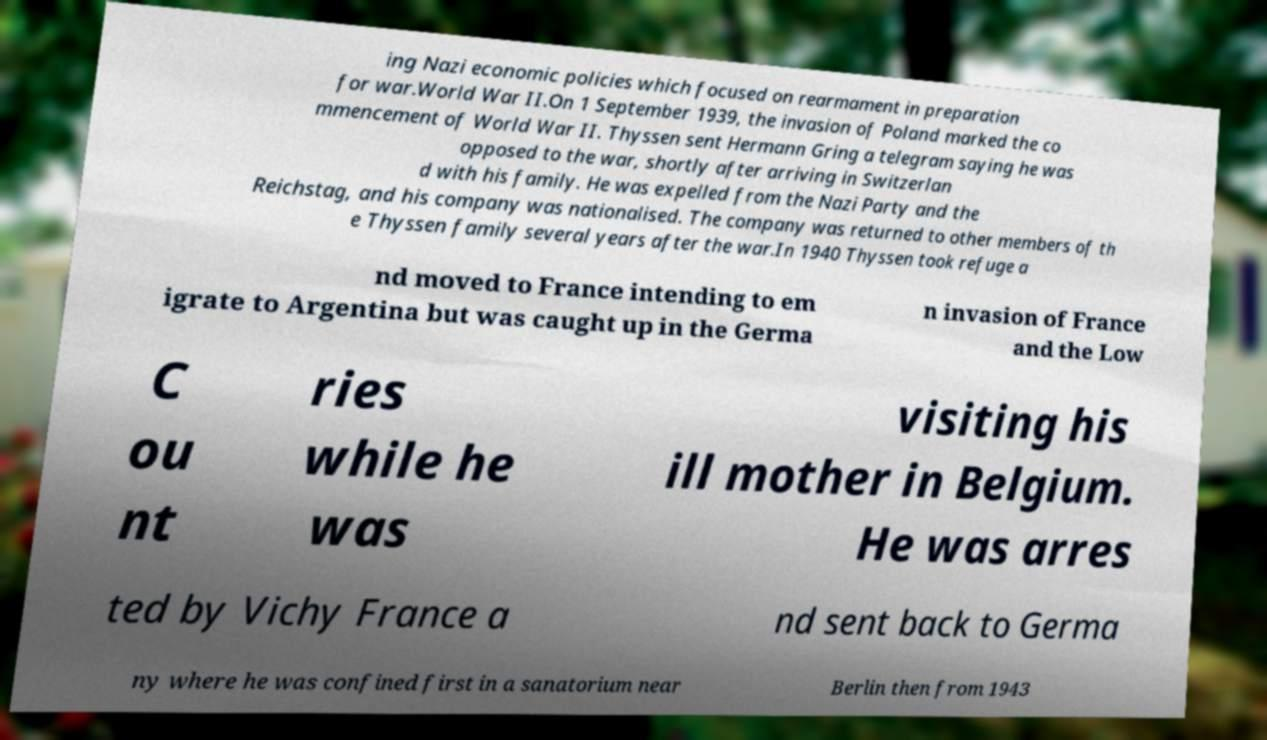I need the written content from this picture converted into text. Can you do that? ing Nazi economic policies which focused on rearmament in preparation for war.World War II.On 1 September 1939, the invasion of Poland marked the co mmencement of World War II. Thyssen sent Hermann Gring a telegram saying he was opposed to the war, shortly after arriving in Switzerlan d with his family. He was expelled from the Nazi Party and the Reichstag, and his company was nationalised. The company was returned to other members of th e Thyssen family several years after the war.In 1940 Thyssen took refuge a nd moved to France intending to em igrate to Argentina but was caught up in the Germa n invasion of France and the Low C ou nt ries while he was visiting his ill mother in Belgium. He was arres ted by Vichy France a nd sent back to Germa ny where he was confined first in a sanatorium near Berlin then from 1943 